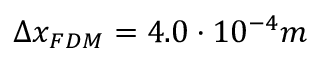<formula> <loc_0><loc_0><loc_500><loc_500>\Delta x _ { F D M } = 4 . 0 \cdot 1 0 ^ { - 4 } m</formula> 